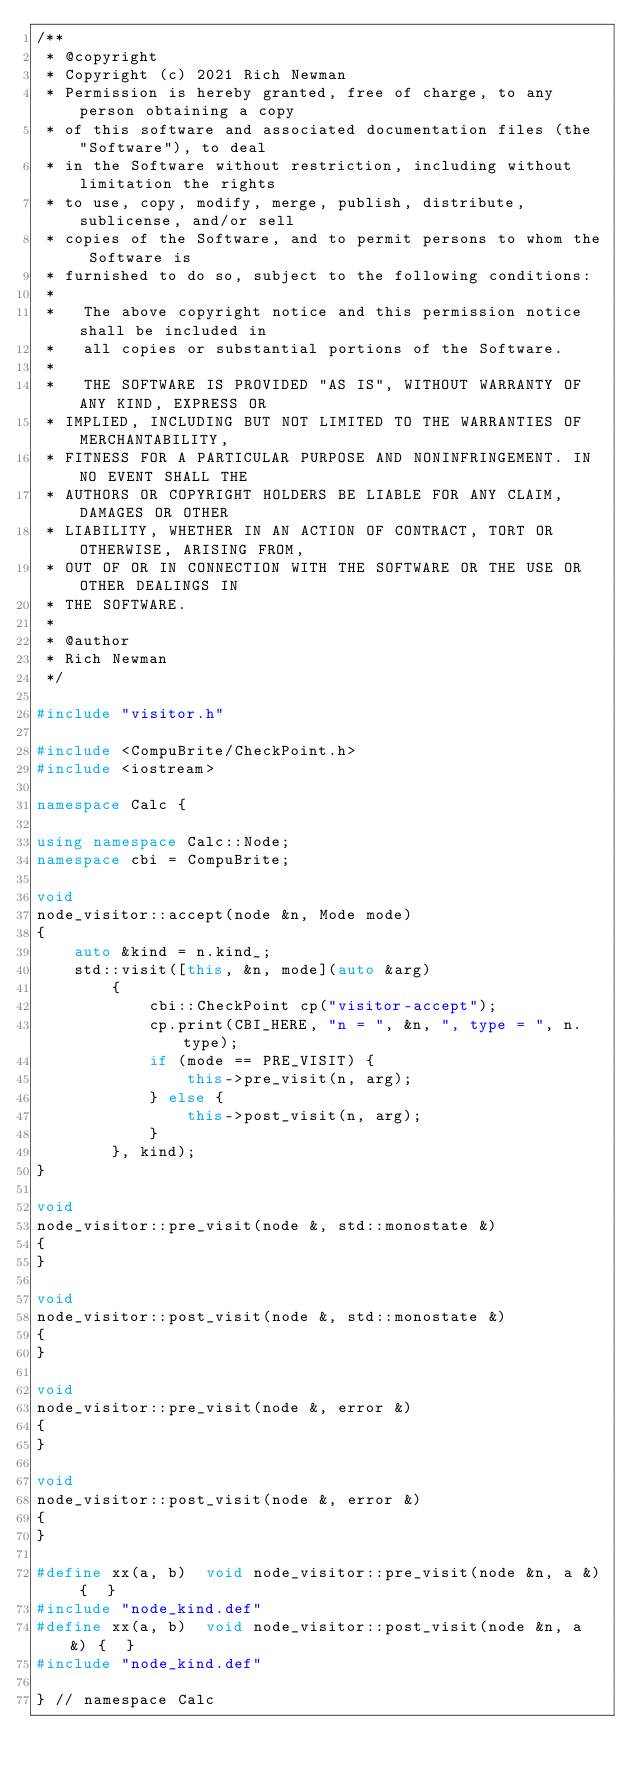Convert code to text. <code><loc_0><loc_0><loc_500><loc_500><_C++_>/**
 * @copyright
 * Copyright (c) 2021 Rich Newman
 * Permission is hereby granted, free of charge, to any person obtaining a copy
 * of this software and associated documentation files (the "Software"), to deal
 * in the Software without restriction, including without limitation the rights
 * to use, copy, modify, merge, publish, distribute, sublicense, and/or sell
 * copies of the Software, and to permit persons to whom the Software is
 * furnished to do so, subject to the following conditions:
 *
 *   The above copyright notice and this permission notice shall be included in
 *   all copies or substantial portions of the Software.
 *
 *   THE SOFTWARE IS PROVIDED "AS IS", WITHOUT WARRANTY OF ANY KIND, EXPRESS OR
 * IMPLIED, INCLUDING BUT NOT LIMITED TO THE WARRANTIES OF MERCHANTABILITY,
 * FITNESS FOR A PARTICULAR PURPOSE AND NONINFRINGEMENT. IN NO EVENT SHALL THE
 * AUTHORS OR COPYRIGHT HOLDERS BE LIABLE FOR ANY CLAIM, DAMAGES OR OTHER
 * LIABILITY, WHETHER IN AN ACTION OF CONTRACT, TORT OR OTHERWISE, ARISING FROM,
 * OUT OF OR IN CONNECTION WITH THE SOFTWARE OR THE USE OR OTHER DEALINGS IN
 * THE SOFTWARE.
 *
 * @author
 * Rich Newman
 */

#include "visitor.h"

#include <CompuBrite/CheckPoint.h>
#include <iostream>

namespace Calc {

using namespace Calc::Node;
namespace cbi = CompuBrite;

void
node_visitor::accept(node &n, Mode mode)
{
    auto &kind = n.kind_;
    std::visit([this, &n, mode](auto &arg)
        {
            cbi::CheckPoint cp("visitor-accept");
            cp.print(CBI_HERE, "n = ", &n, ", type = ", n.type);
            if (mode == PRE_VISIT) {
                this->pre_visit(n, arg);
            } else {
                this->post_visit(n, arg);
            }
        }, kind);
}

void
node_visitor::pre_visit(node &, std::monostate &)
{
}

void
node_visitor::post_visit(node &, std::monostate &)
{
}

void
node_visitor::pre_visit(node &, error &)
{
}

void
node_visitor::post_visit(node &, error &)
{
}

#define xx(a, b)  void node_visitor::pre_visit(node &n, a &) {  }
#include "node_kind.def"
#define xx(a, b)  void node_visitor::post_visit(node &n, a &) {  }
#include "node_kind.def"

} // namespace Calc
</code> 